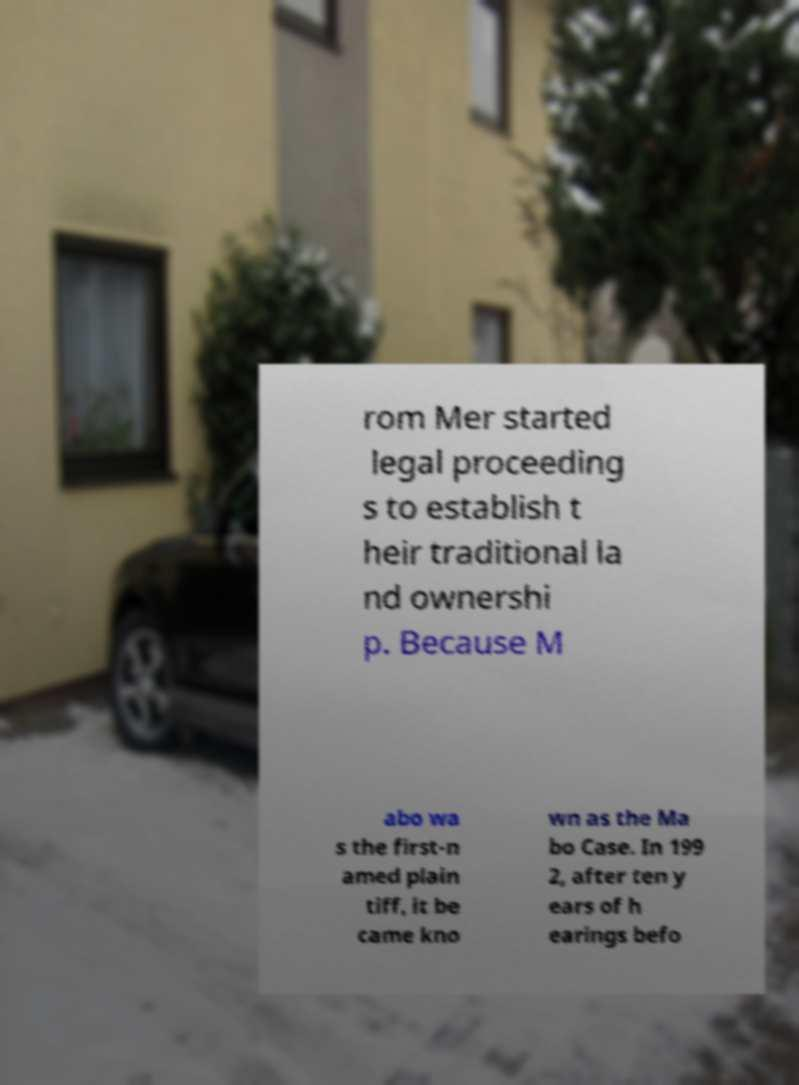Could you extract and type out the text from this image? rom Mer started legal proceeding s to establish t heir traditional la nd ownershi p. Because M abo wa s the first-n amed plain tiff, it be came kno wn as the Ma bo Case. In 199 2, after ten y ears of h earings befo 